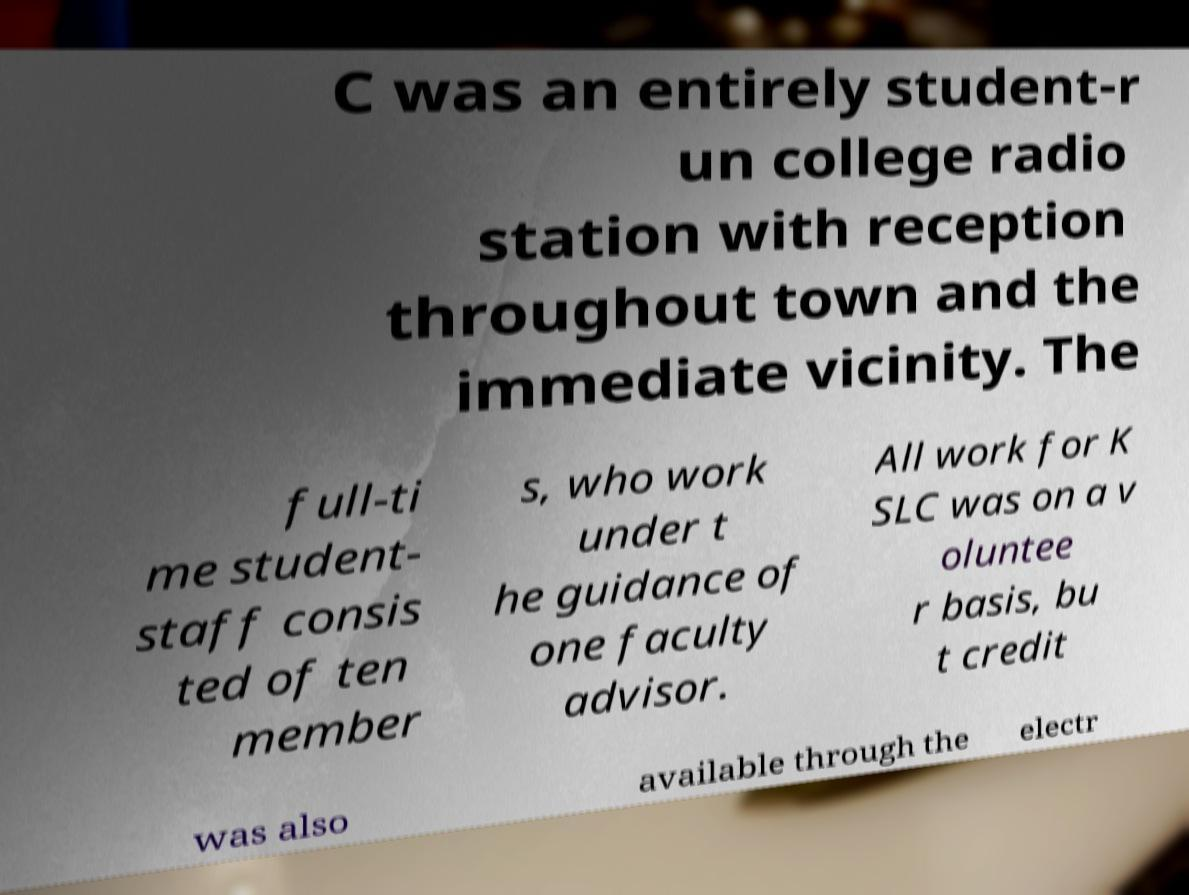What messages or text are displayed in this image? I need them in a readable, typed format. C was an entirely student-r un college radio station with reception throughout town and the immediate vicinity. The full-ti me student- staff consis ted of ten member s, who work under t he guidance of one faculty advisor. All work for K SLC was on a v oluntee r basis, bu t credit was also available through the electr 